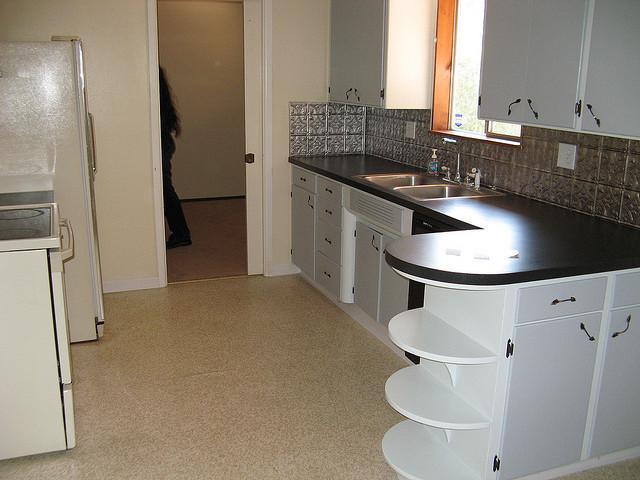How many white shelves are in this kitchen?
Give a very brief answer. 3. How many people are in the photo?
Give a very brief answer. 1. How many spoons are on this plate?
Give a very brief answer. 0. 